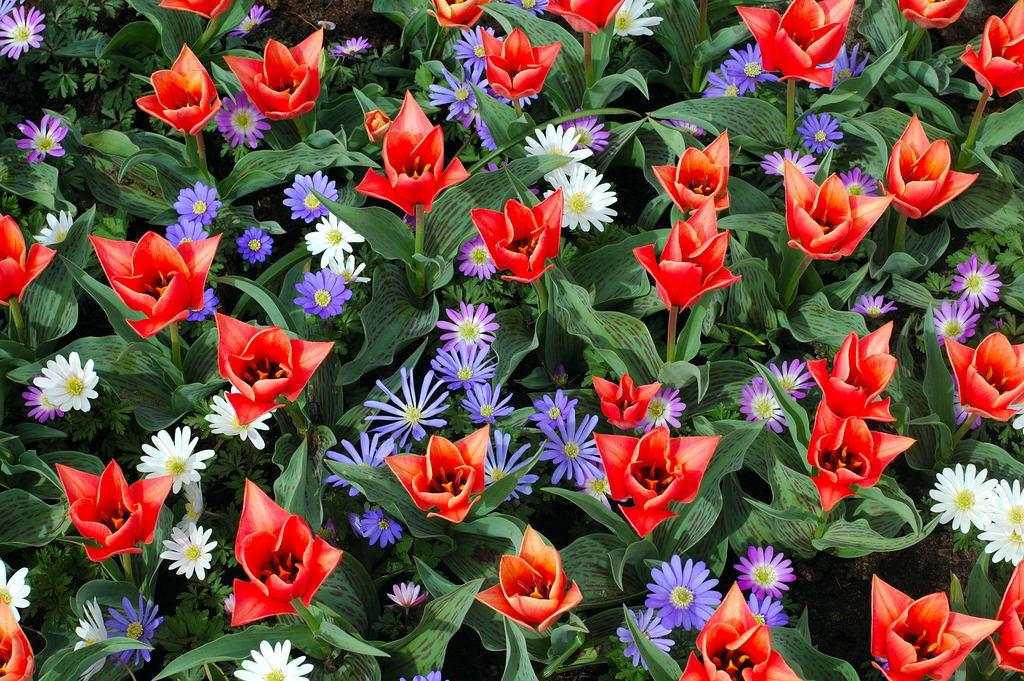What type of artwork is shown in the image? The image is a painting. What is the main subject of the painting? The painting depicts flowers. Are there any other elements related to plants in the painting? Yes, the painting also depicts plants. What type of paste is used to create the texture of the flowers in the painting? There is no mention of paste being used in the creation of the painting, and the texture of the flowers is a result of the artist's technique and materials. 